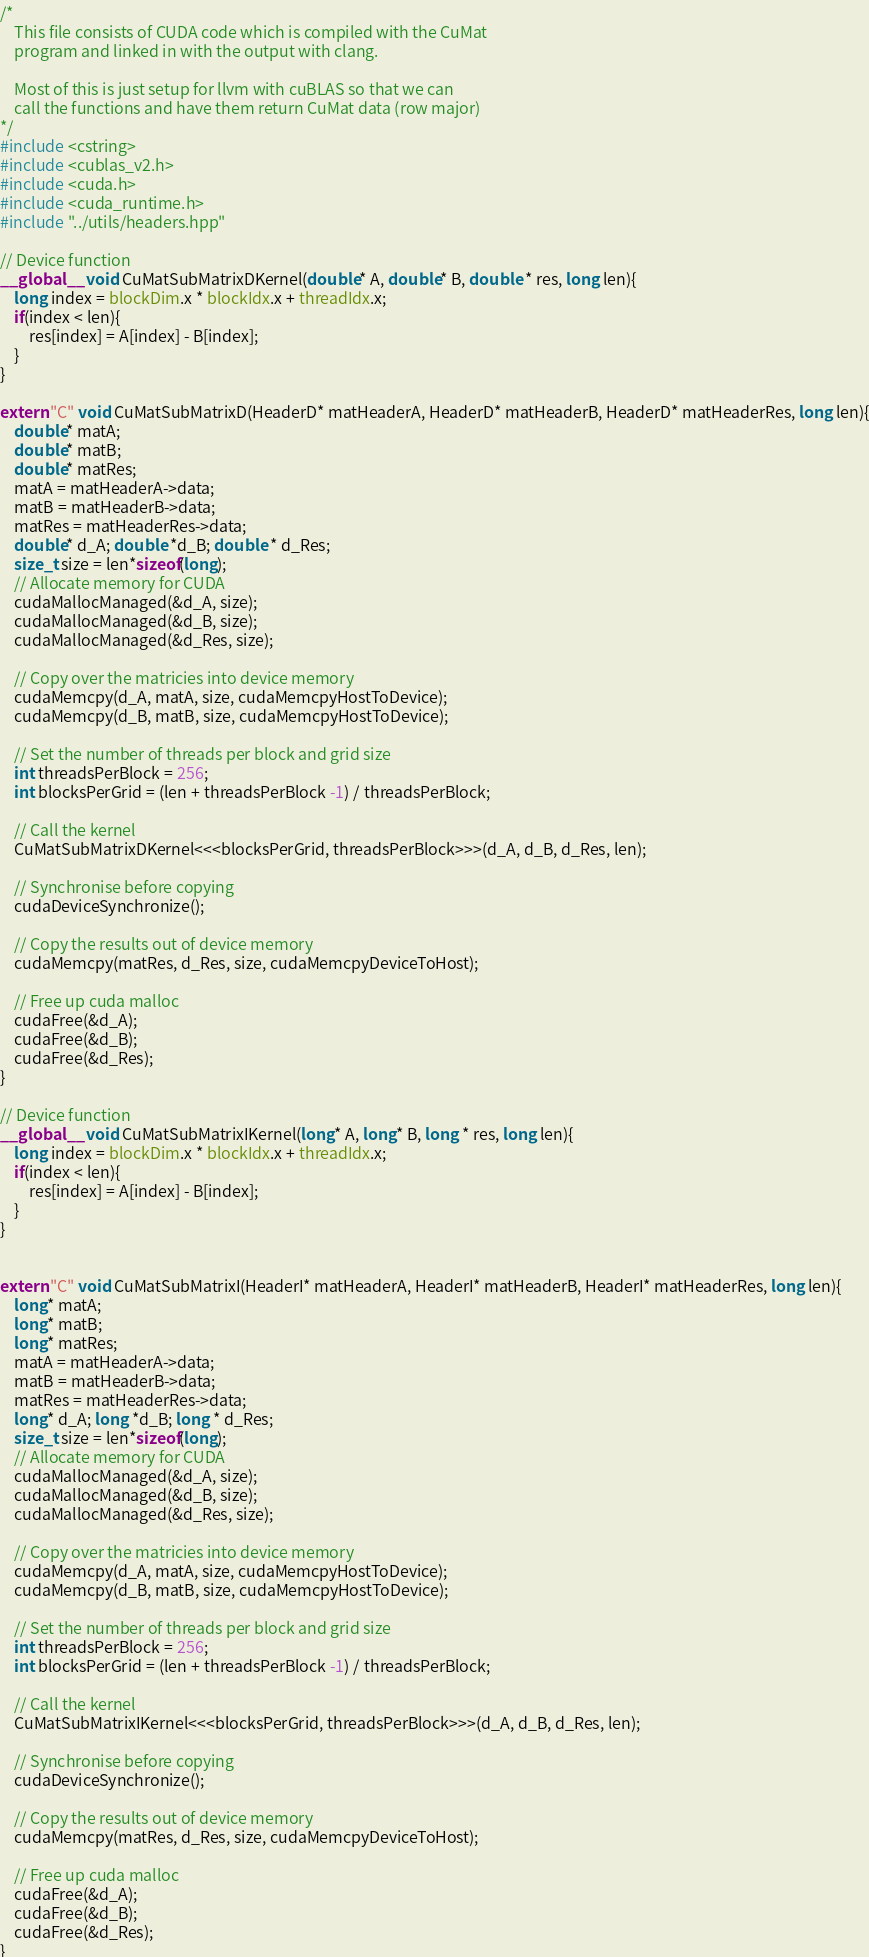Convert code to text. <code><loc_0><loc_0><loc_500><loc_500><_Cuda_>/*
    This file consists of CUDA code which is compiled with the CuMat
    program and linked in with the output with clang.

    Most of this is just setup for llvm with cuBLAS so that we can
    call the functions and have them return CuMat data (row major)
*/
#include <cstring>
#include <cublas_v2.h>
#include <cuda.h>
#include <cuda_runtime.h>
#include "../utils/headers.hpp"

// Device function
__global__ void CuMatSubMatrixDKernel(double* A, double* B, double * res, long len){
    long index = blockDim.x * blockIdx.x + threadIdx.x;
    if(index < len){
        res[index] = A[index] - B[index];
    }
}

extern "C" void CuMatSubMatrixD(HeaderD* matHeaderA, HeaderD* matHeaderB, HeaderD* matHeaderRes, long len){
    double* matA;
    double* matB;
    double* matRes;
    matA = matHeaderA->data;
    matB = matHeaderB->data;
    matRes = matHeaderRes->data;
    double* d_A; double *d_B; double * d_Res;
    size_t size = len*sizeof(long);
    // Allocate memory for CUDA
    cudaMallocManaged(&d_A, size);
    cudaMallocManaged(&d_B, size);
    cudaMallocManaged(&d_Res, size);

    // Copy over the matricies into device memory
    cudaMemcpy(d_A, matA, size, cudaMemcpyHostToDevice);
    cudaMemcpy(d_B, matB, size, cudaMemcpyHostToDevice);

    // Set the number of threads per block and grid size
    int threadsPerBlock = 256;
    int blocksPerGrid = (len + threadsPerBlock -1) / threadsPerBlock;

    // Call the kernel
    CuMatSubMatrixDKernel<<<blocksPerGrid, threadsPerBlock>>>(d_A, d_B, d_Res, len);

    // Synchronise before copying
    cudaDeviceSynchronize();

    // Copy the results out of device memory
    cudaMemcpy(matRes, d_Res, size, cudaMemcpyDeviceToHost);

    // Free up cuda malloc
    cudaFree(&d_A);
    cudaFree(&d_B);
    cudaFree(&d_Res);
}

// Device function
__global__ void CuMatSubMatrixIKernel(long* A, long* B, long * res, long len){
    long index = blockDim.x * blockIdx.x + threadIdx.x;
    if(index < len){
        res[index] = A[index] - B[index];
    }
}


extern "C" void CuMatSubMatrixI(HeaderI* matHeaderA, HeaderI* matHeaderB, HeaderI* matHeaderRes, long len){
    long* matA;
    long* matB;
    long* matRes;
    matA = matHeaderA->data;
    matB = matHeaderB->data;
    matRes = matHeaderRes->data;
    long* d_A; long *d_B; long * d_Res;
    size_t size = len*sizeof(long);
    // Allocate memory for CUDA
    cudaMallocManaged(&d_A, size);
    cudaMallocManaged(&d_B, size);
    cudaMallocManaged(&d_Res, size);

    // Copy over the matricies into device memory
    cudaMemcpy(d_A, matA, size, cudaMemcpyHostToDevice);
    cudaMemcpy(d_B, matB, size, cudaMemcpyHostToDevice);

    // Set the number of threads per block and grid size
    int threadsPerBlock = 256;
    int blocksPerGrid = (len + threadsPerBlock -1) / threadsPerBlock;

    // Call the kernel
    CuMatSubMatrixIKernel<<<blocksPerGrid, threadsPerBlock>>>(d_A, d_B, d_Res, len);

    // Synchronise before copying
    cudaDeviceSynchronize();

    // Copy the results out of device memory
    cudaMemcpy(matRes, d_Res, size, cudaMemcpyDeviceToHost);

    // Free up cuda malloc
    cudaFree(&d_A);
    cudaFree(&d_B);
    cudaFree(&d_Res);
}
</code> 